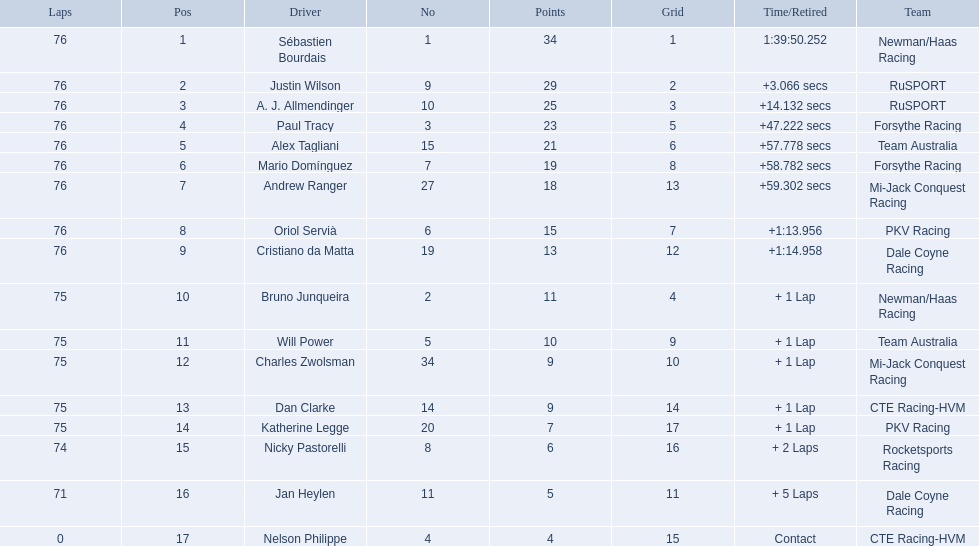What was alex taglini's final score in the tecate grand prix? 21. What was paul tracy's final score in the tecate grand prix? 23. Which driver finished first? Paul Tracy. 